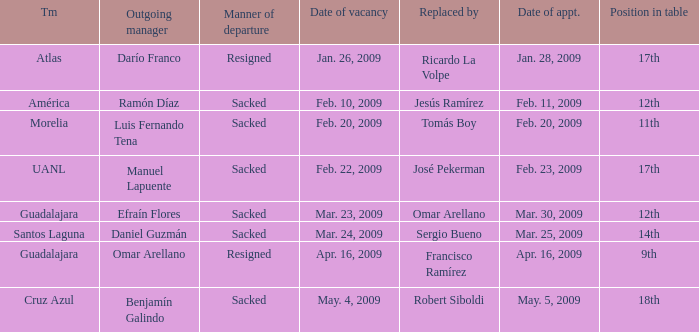What is Team, when Replaced By is "Jesús Ramírez"? América. 